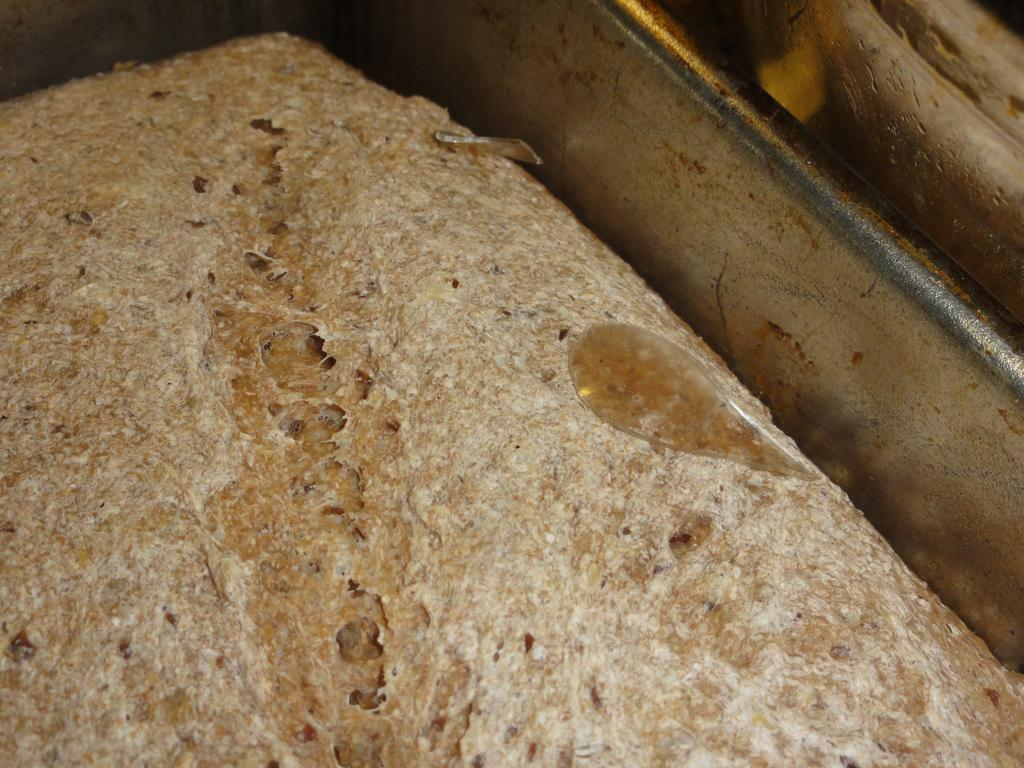What is the main subject of the image? There is a food item in the image. What type of voice can be heard coming from the food item in the image? There is no voice coming from the food item in the image, as food items do not have the ability to produce sound. 